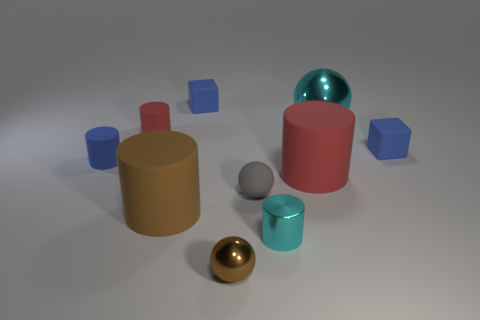Is there a brown matte cylinder that has the same size as the cyan metallic cylinder?
Your answer should be very brief. No. There is a large object that is left of the brown metallic thing; does it have the same color as the small shiny ball?
Provide a short and direct response. Yes. What number of things are either tiny cyan metallic things or tiny brown things?
Your answer should be very brief. 2. Do the cyan shiny object that is in front of the matte ball and the big ball have the same size?
Offer a terse response. No. There is a cylinder that is in front of the tiny gray object and on the left side of the cyan shiny cylinder; what is its size?
Offer a terse response. Large. What number of other things are the same shape as the big red thing?
Offer a very short reply. 4. How many other objects are there of the same material as the tiny brown thing?
Your response must be concise. 2. What size is the brown rubber object that is the same shape as the tiny red thing?
Keep it short and to the point. Large. Is the metallic cylinder the same color as the large shiny object?
Keep it short and to the point. Yes. What is the color of the tiny cylinder that is both to the right of the blue cylinder and left of the tiny brown sphere?
Give a very brief answer. Red. 